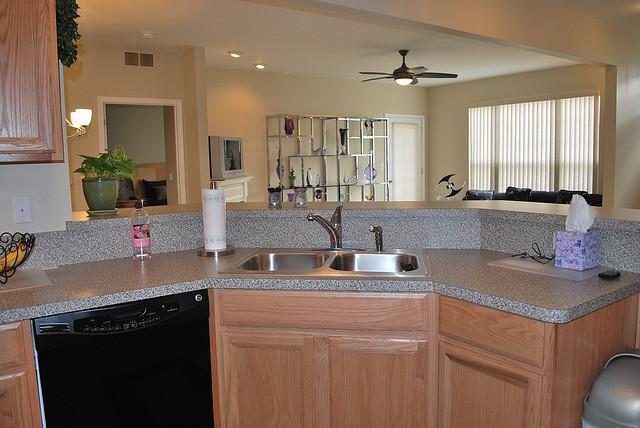How many lights are on?
Give a very brief answer. 5. How many lights are hanging?
Give a very brief answer. 1. How many sinks are there?
Give a very brief answer. 2. How many people are in the water?
Give a very brief answer. 0. 